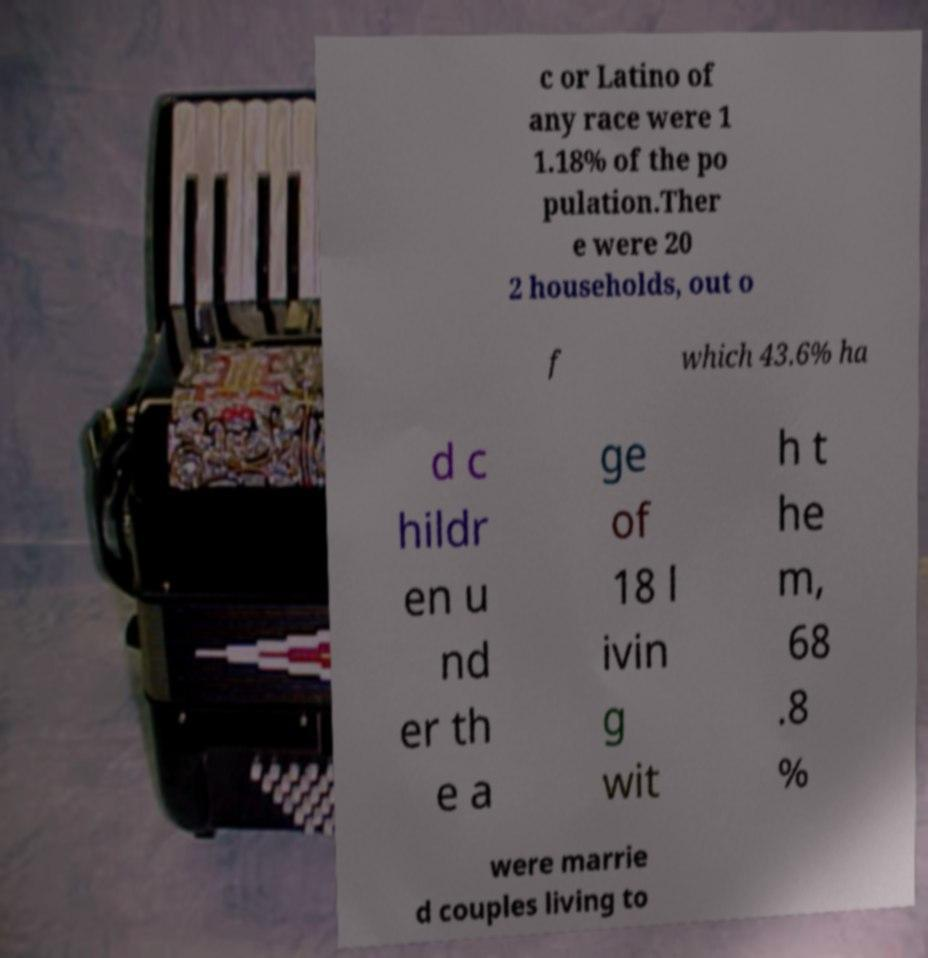Please read and relay the text visible in this image. What does it say? c or Latino of any race were 1 1.18% of the po pulation.Ther e were 20 2 households, out o f which 43.6% ha d c hildr en u nd er th e a ge of 18 l ivin g wit h t he m, 68 .8 % were marrie d couples living to 